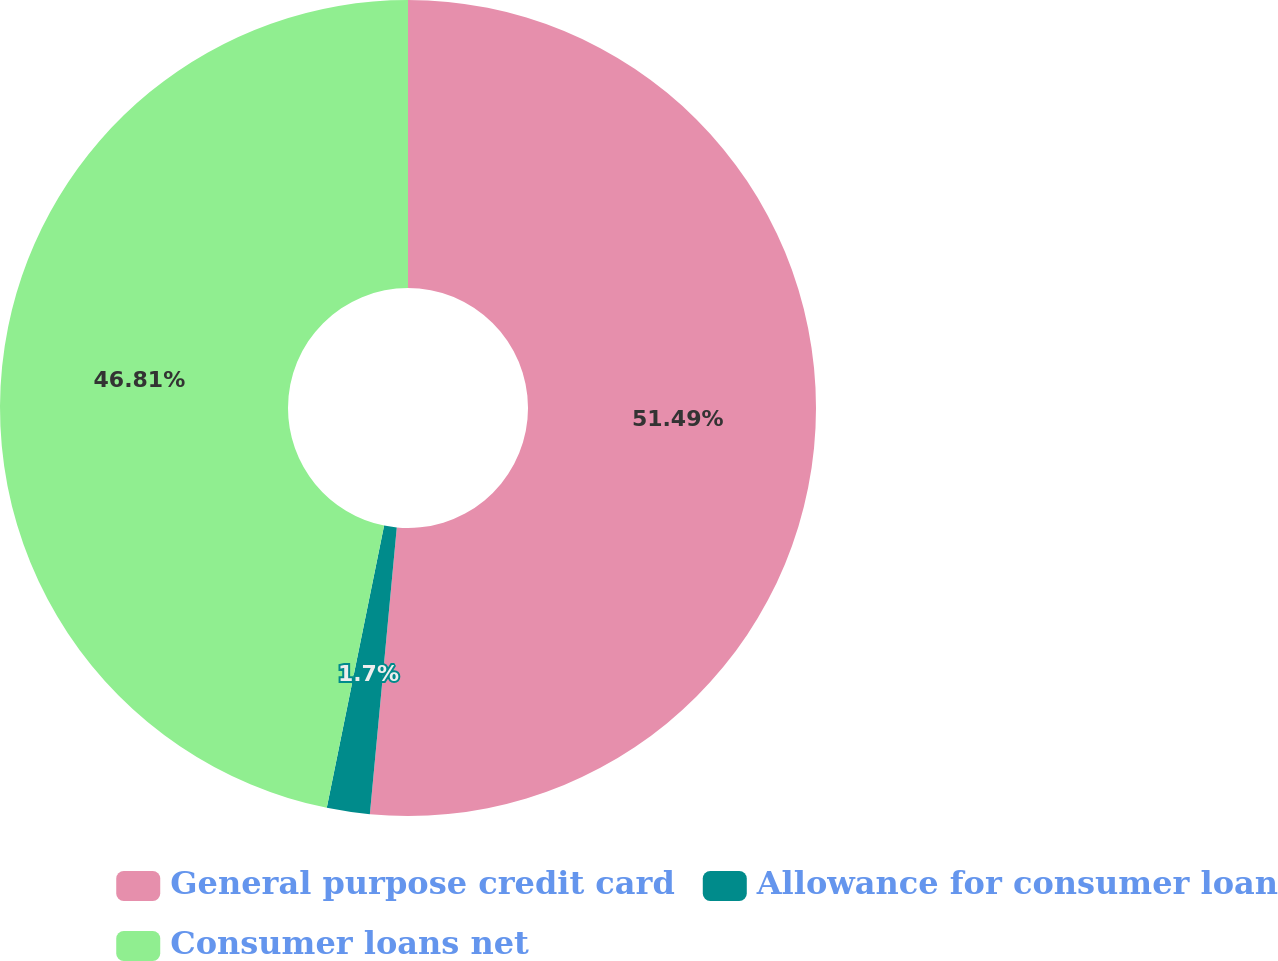Convert chart. <chart><loc_0><loc_0><loc_500><loc_500><pie_chart><fcel>General purpose credit card<fcel>Allowance for consumer loan<fcel>Consumer loans net<nl><fcel>51.49%<fcel>1.7%<fcel>46.81%<nl></chart> 